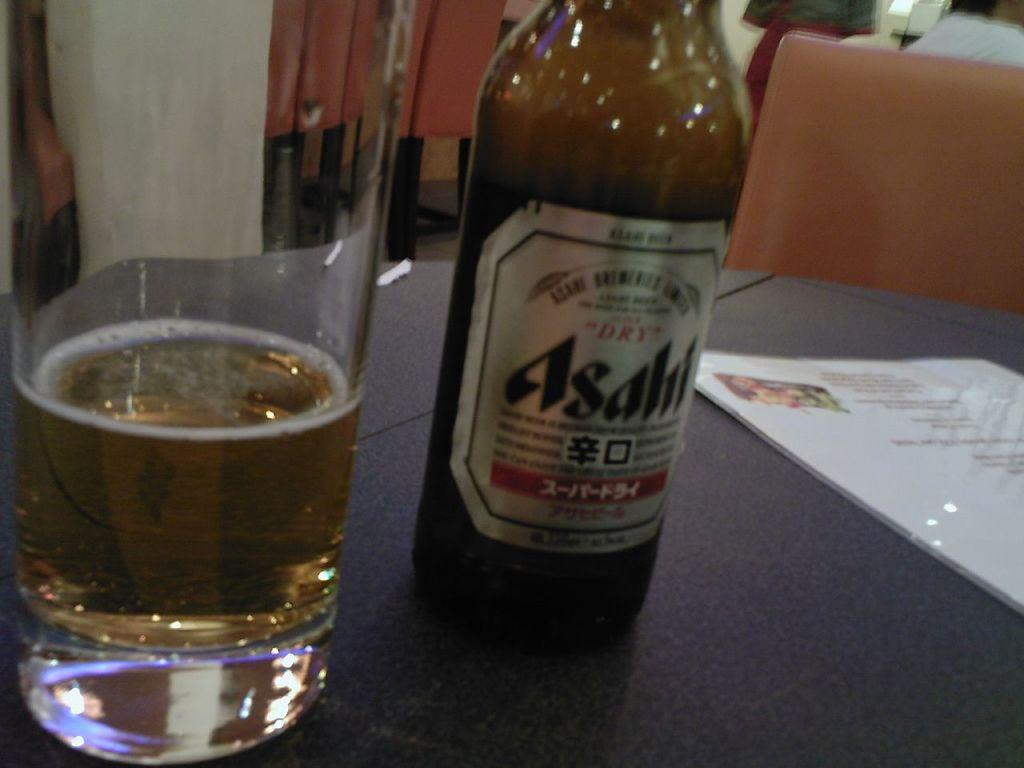<image>
Write a terse but informative summary of the picture. A bottle of Asahl next to a glass 